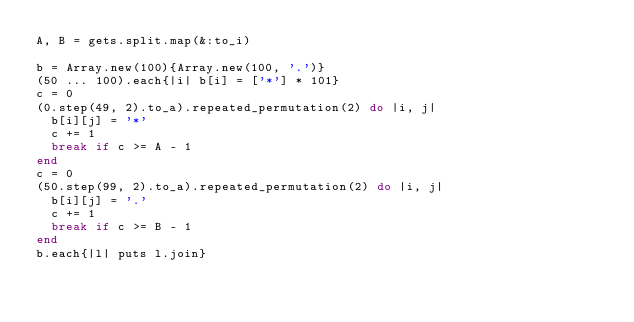<code> <loc_0><loc_0><loc_500><loc_500><_Ruby_>A, B = gets.split.map(&:to_i)

b = Array.new(100){Array.new(100, '.')}
(50 ... 100).each{|i| b[i] = ['*'] * 101}
c = 0
(0.step(49, 2).to_a).repeated_permutation(2) do |i, j|
  b[i][j] = '*'
  c += 1
  break if c >= A - 1
end
c = 0
(50.step(99, 2).to_a).repeated_permutation(2) do |i, j|
  b[i][j] = '.'
  c += 1
  break if c >= B - 1
end
b.each{|l| puts l.join}</code> 